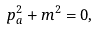Convert formula to latex. <formula><loc_0><loc_0><loc_500><loc_500>p _ { a } ^ { 2 } + m ^ { 2 } = 0 ,</formula> 